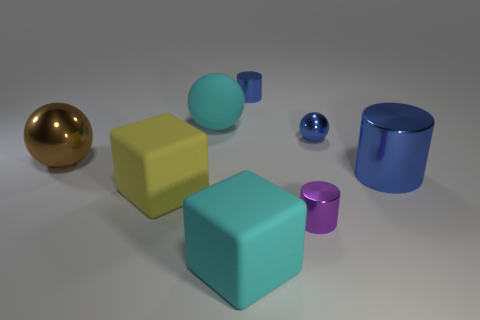Subtract all small metal cylinders. How many cylinders are left? 1 Subtract all purple balls. How many blue cylinders are left? 2 Subtract 1 cylinders. How many cylinders are left? 2 Add 2 small metal spheres. How many objects exist? 10 Subtract all balls. How many objects are left? 5 Add 3 tiny purple metal objects. How many tiny purple metal objects are left? 4 Add 8 tiny purple shiny cylinders. How many tiny purple shiny cylinders exist? 9 Subtract 1 purple cylinders. How many objects are left? 7 Subtract all blocks. Subtract all big metallic things. How many objects are left? 4 